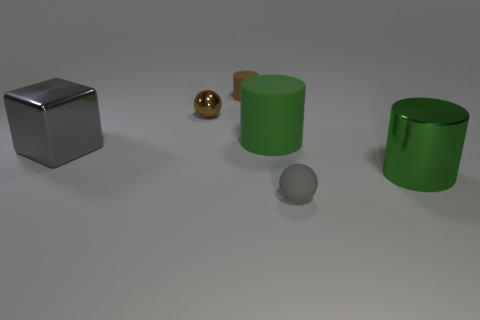Add 1 small metal balls. How many objects exist? 7 Subtract all cubes. How many objects are left? 5 Subtract all gray spheres. Subtract all rubber spheres. How many objects are left? 4 Add 5 gray matte balls. How many gray matte balls are left? 6 Add 6 small metal spheres. How many small metal spheres exist? 7 Subtract 0 blue cylinders. How many objects are left? 6 